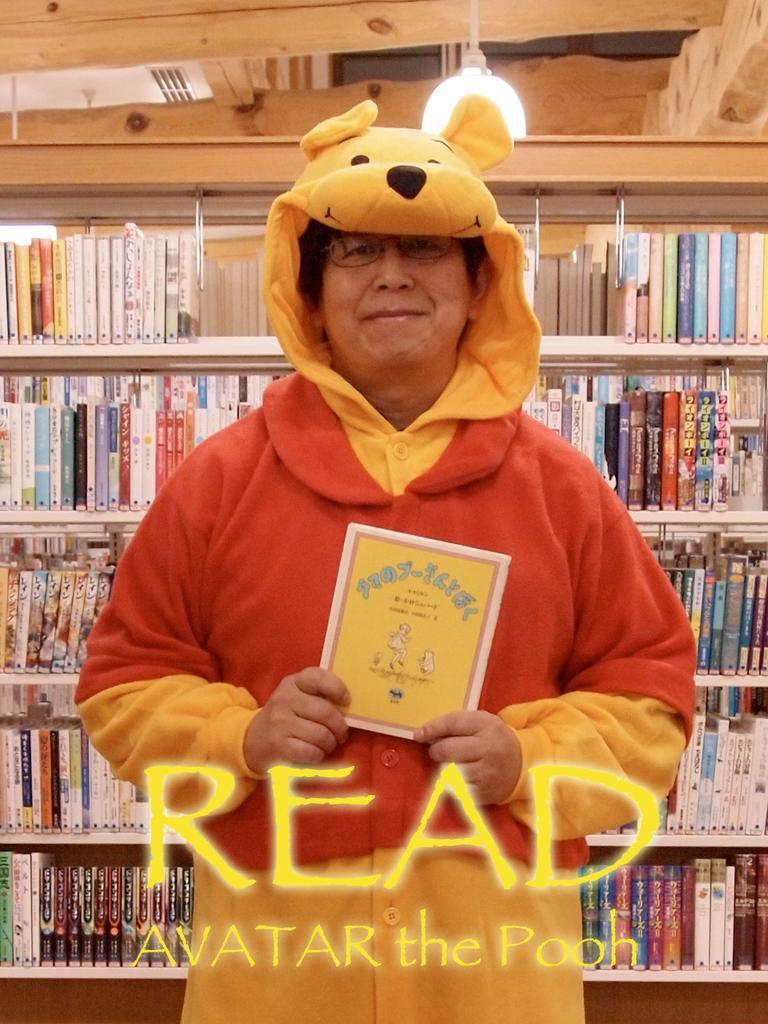How would you summarize this image in a sentence or two? In the front of the image I can see a person is standing and holding a card. In the background of the image there is a light, rack and books. Something is written on the image. 